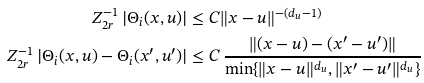<formula> <loc_0><loc_0><loc_500><loc_500>Z _ { 2 r } ^ { - 1 } \, | \Theta _ { i } ( x , u ) | & \leq C { \| x - u \| ^ { - ( d _ { u } - 1 ) } } \\ Z _ { 2 r } ^ { - 1 } \, | \Theta _ { i } ( x , u ) - \Theta _ { i } ( x ^ { \prime } , u ^ { \prime } ) | & \leq C \, \frac { \| ( x - u ) - ( x ^ { \prime } - u ^ { \prime } ) \| } { \min \{ \| x - u \| ^ { d _ { u } } , \| x ^ { \prime } - u ^ { \prime } \| ^ { d _ { u } } \} }</formula> 